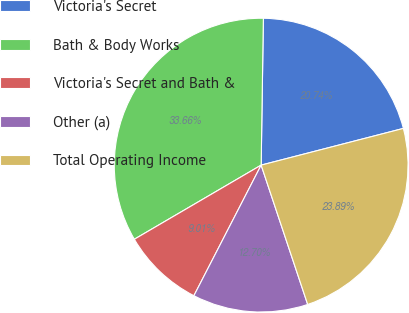Convert chart to OTSL. <chart><loc_0><loc_0><loc_500><loc_500><pie_chart><fcel>Victoria's Secret<fcel>Bath & Body Works<fcel>Victoria's Secret and Bath &<fcel>Other (a)<fcel>Total Operating Income<nl><fcel>20.74%<fcel>33.66%<fcel>9.01%<fcel>12.7%<fcel>23.89%<nl></chart> 